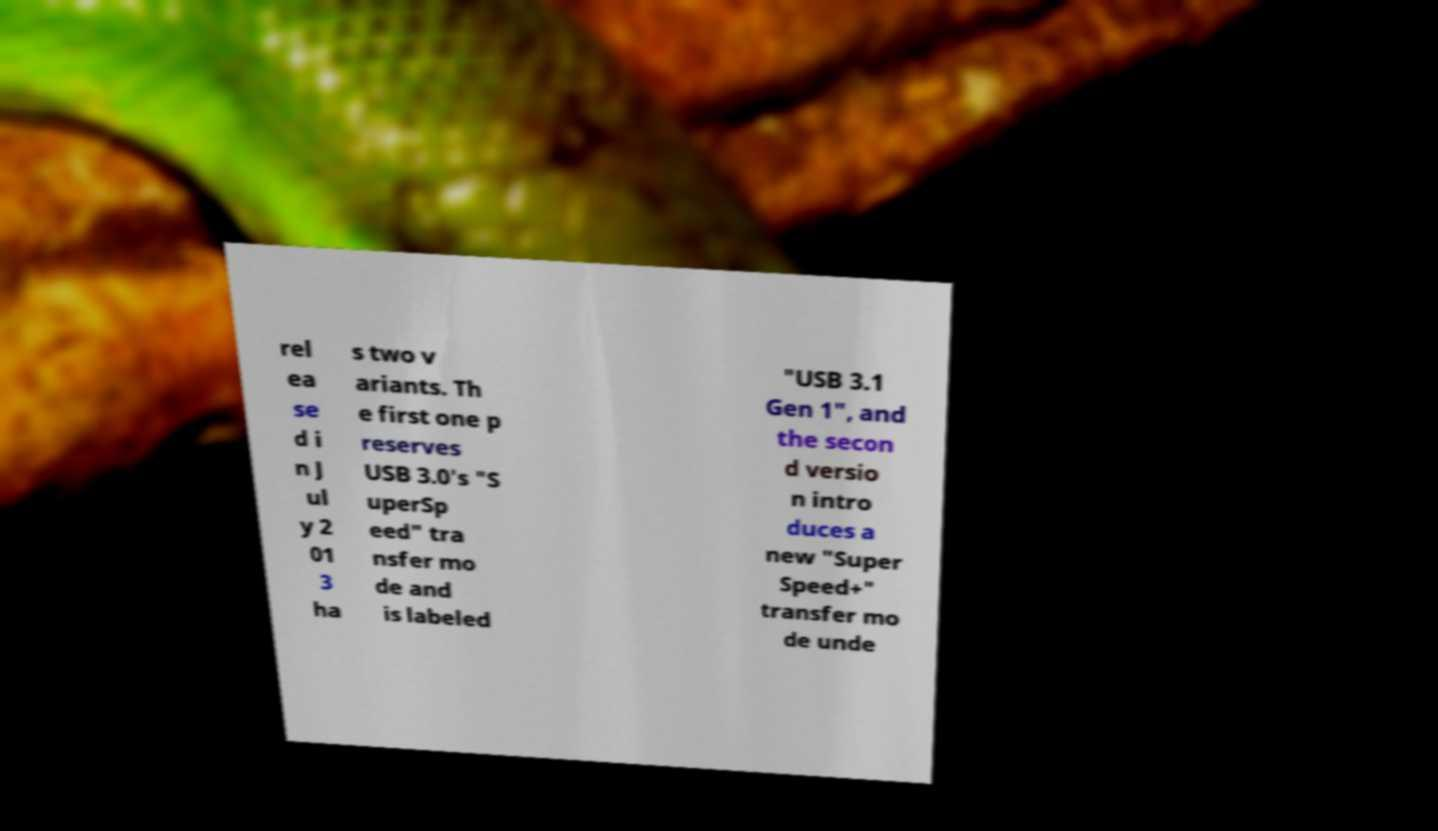There's text embedded in this image that I need extracted. Can you transcribe it verbatim? rel ea se d i n J ul y 2 01 3 ha s two v ariants. Th e first one p reserves USB 3.0's "S uperSp eed" tra nsfer mo de and is labeled "USB 3.1 Gen 1", and the secon d versio n intro duces a new "Super Speed+" transfer mo de unde 